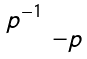<formula> <loc_0><loc_0><loc_500><loc_500>\begin{smallmatrix} p ^ { - 1 } & \\ & - p \end{smallmatrix}</formula> 